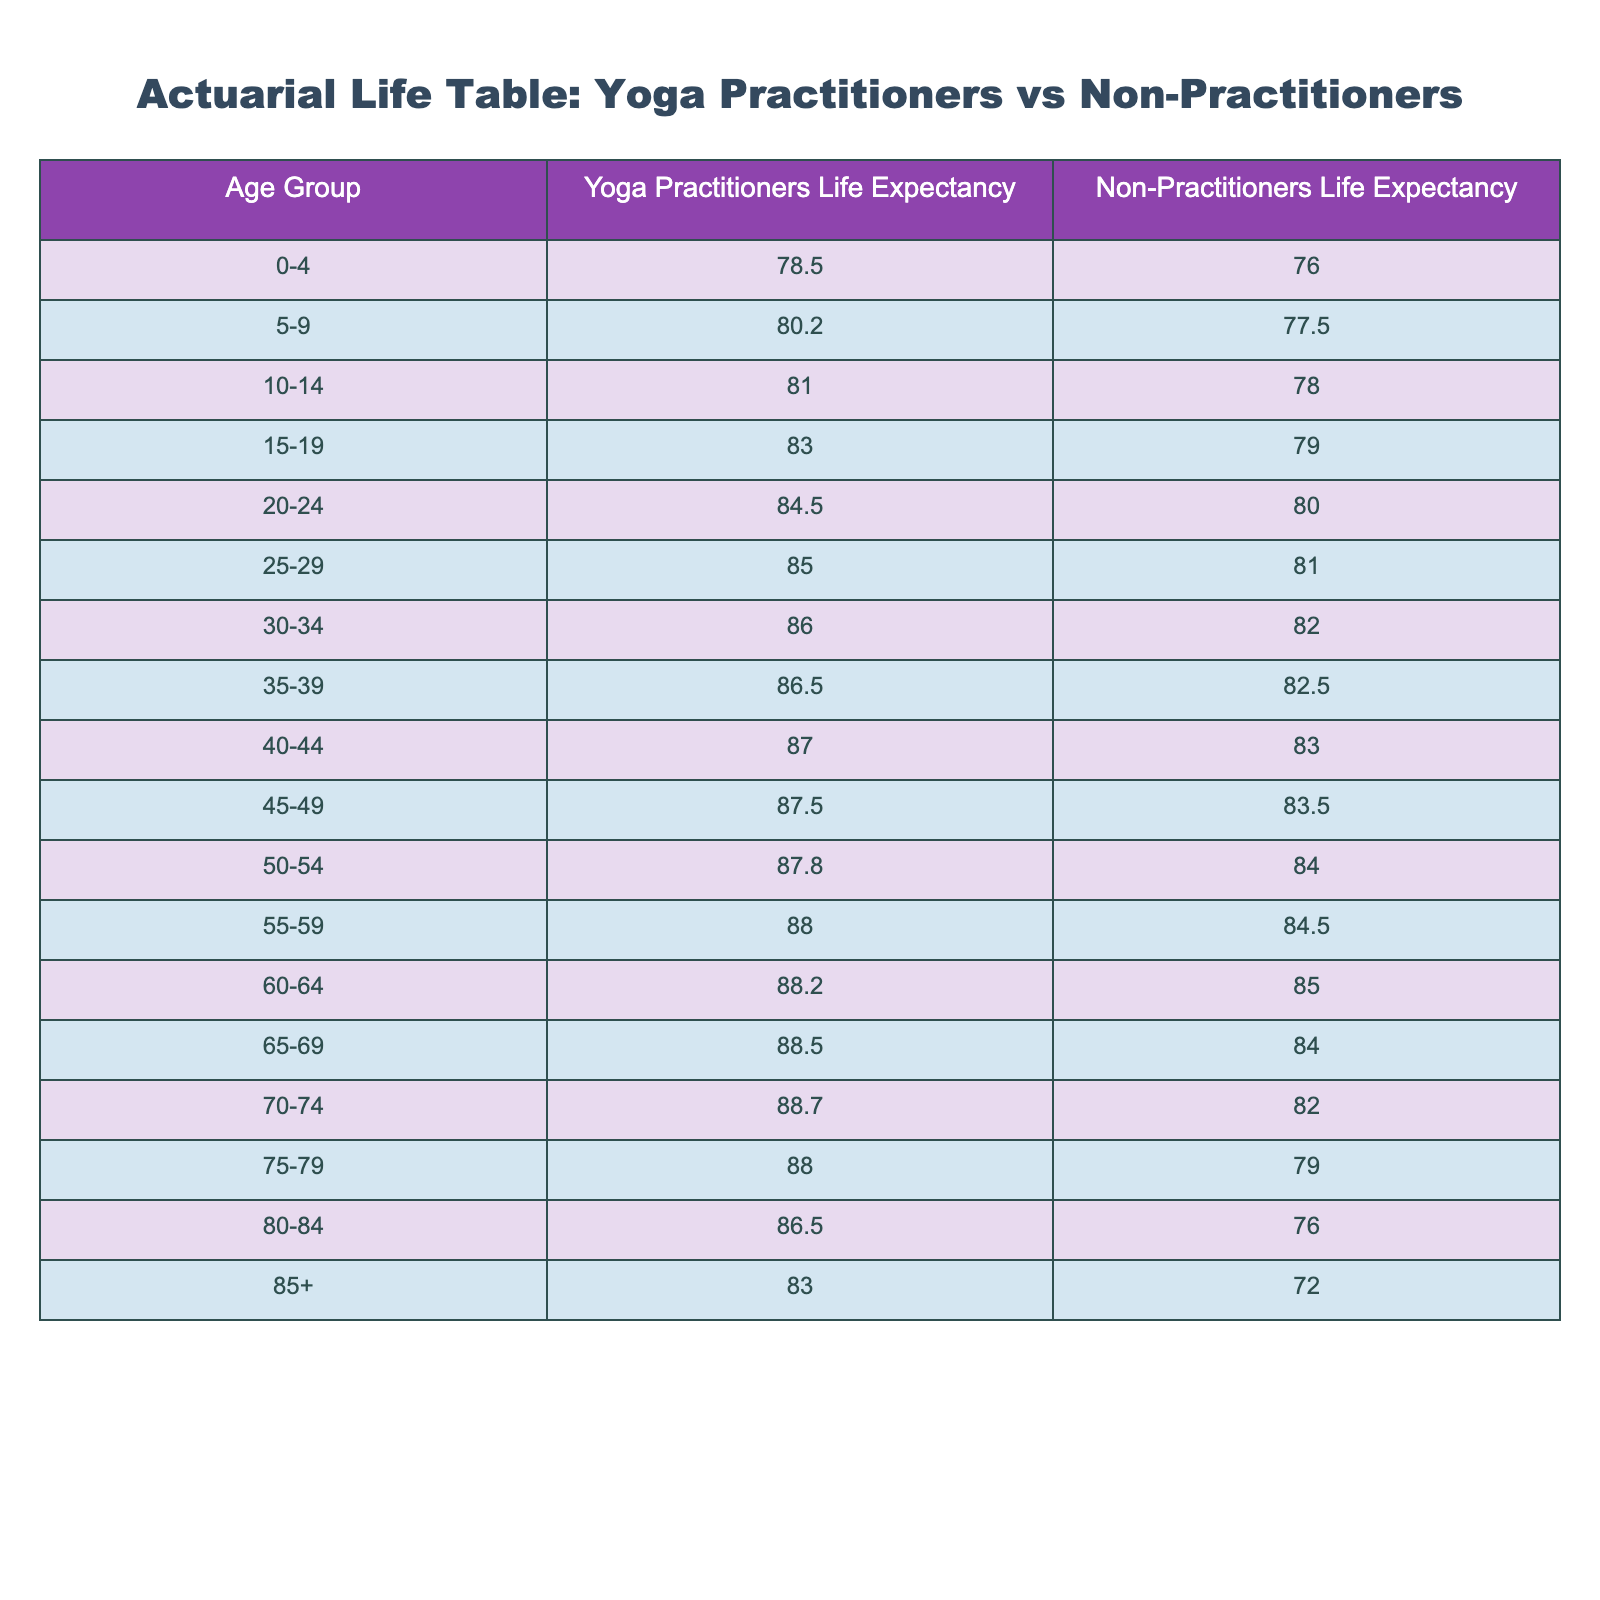What is the life expectancy for yoga practitioners aged 30-34? The table shows that the life expectancy for yoga practitioners in the age group 30-34 is 86.0.
Answer: 86.0 What is the life expectancy for non-practitioners aged 70-74? According to the table, the life expectancy for non-practitioners in the age group 70-74 is 82.0.
Answer: 82.0 What is the difference in life expectancy between yoga practitioners and non-practitioners for the age group 50-54? For yoga practitioners aged 50-54, the life expectancy is 87.8, while for non-practitioners it is 84.0. The difference is 87.8 - 84.0 = 3.8.
Answer: 3.8 Do yoga practitioners have a higher life expectancy than non-practitioners in the age group 85+? The life expectancy for yoga practitioners aged 85+ is 83.0, and for non-practitioners, it is 72.0. Since 83.0 is greater than 72.0, the answer is yes.
Answer: Yes What is the average life expectancy for yoga practitioners across all age groups? To find the average, sum the life expectancies for each age group of yoga practitioners: (78.5 + 80.2 + 81.0 + 83.0 + 84.5 + 85.0 + 86.0 + 86.5 + 87.0 + 87.5 + 87.8 + 88.0 + 88.2 + 88.5 + 88.7 + 88.0 + 86.5 + 83.0) = 1527.9. There are 18 age groups, so the average is 1527.9 / 18 = 84.8.
Answer: 84.8 What is the life expectancy for yoga practitioners in the age group 45-49? The table indicates that the life expectancy for yoga practitioners in the age group 45-49 is 87.5.
Answer: 87.5 Is it true that non-practitioners aged 60-64 have a lower life expectancy than yoga practitioners of the same age group? For non-practitioners aged 60-64, the life expectancy is 85.0, and for yoga practitioners, it is 88.2. Since 85.0 is less than 88.2, the answer is true.
Answer: True What is the combined life expectancy for non-practitioners in the age groups 0-4 and 5-9? For non-practitioners, the life expectancy for age group 0-4 is 76.0 and for 5-9 is 77.5. The combined life expectancy is 76.0 + 77.5 = 153.5.
Answer: 153.5 What is the age group with the highest life expectancy for yoga practitioners? The age group 55-59 has a life expectancy of 88.0, which is the highest among the yoga practitioners' categories.
Answer: 55-59 What is the median life expectancy for non-practitioners based on the age groups provided? First, list the life expectancies for non-practitioners in ascending order: 72.0, 76.0, 77.5, 78.0, 79.0, 79.0, 80.0, 81.0, 83.0, 83.5, 84.0, 84.5, 85.0, 84.0, 82.0. There are 18 values, so the median is the average of the 9th and 10th values: (83.0 + 83.5) / 2 = 83.25.
Answer: 83.25 